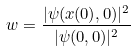<formula> <loc_0><loc_0><loc_500><loc_500>w = \frac { | \psi ( x ( 0 ) , 0 ) | ^ { 2 } } { | \psi ( 0 , 0 ) | ^ { 2 } }</formula> 